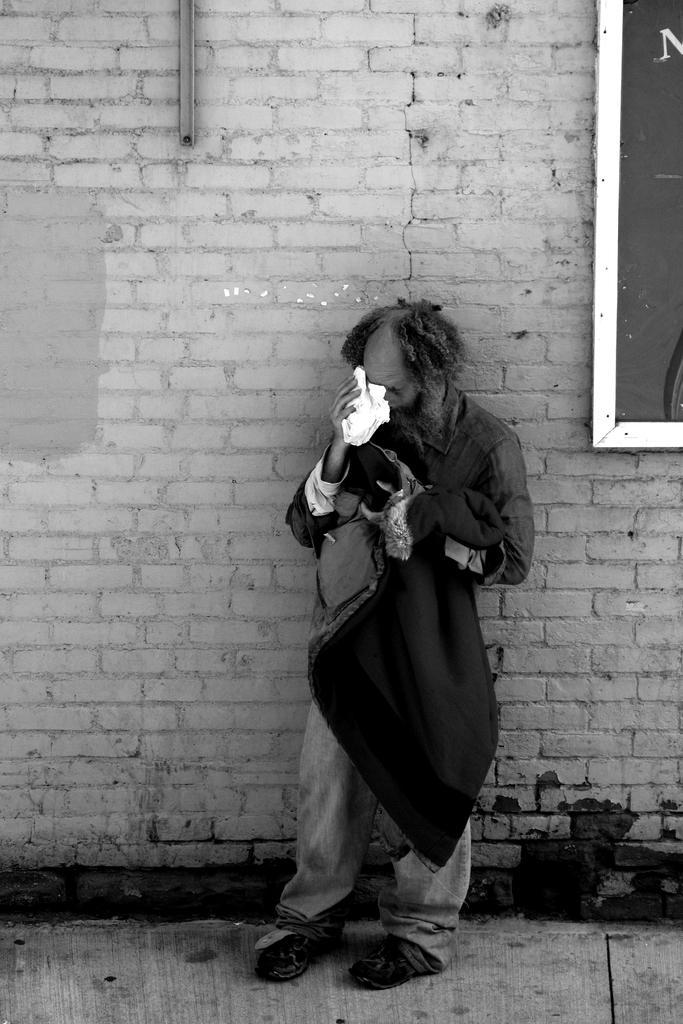Can you describe this image briefly? In this black and white picture there is a person standing. He is holding the clothes. Background there is a wall having a board attached to it. 